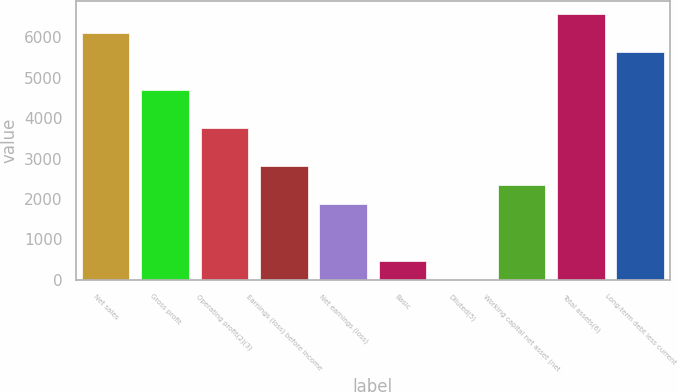Convert chart. <chart><loc_0><loc_0><loc_500><loc_500><bar_chart><fcel>Net sales<fcel>Gross profit<fcel>Operating profit(2)(3)<fcel>Earnings (loss) before income<fcel>Net earnings (loss)<fcel>Basic<fcel>Diluted(5)<fcel>Working capital net asset (net<fcel>Total assets(6)<fcel>Long-term debt less current<nl><fcel>6114.7<fcel>4704.07<fcel>3763.65<fcel>2823.23<fcel>1882.81<fcel>472.18<fcel>1.97<fcel>2353.02<fcel>6584.91<fcel>5644.49<nl></chart> 